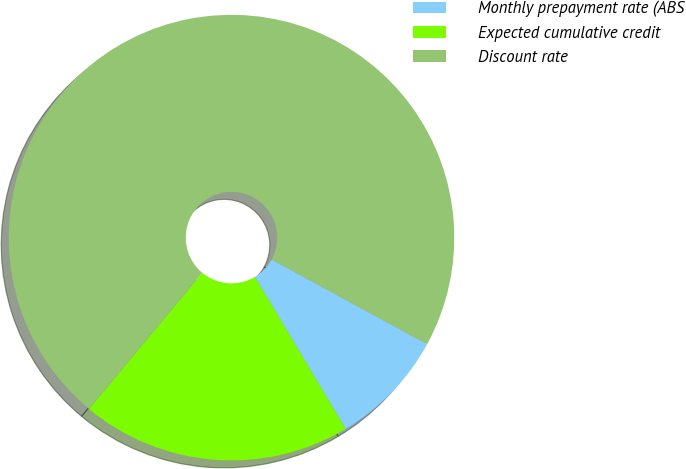Convert chart to OTSL. <chart><loc_0><loc_0><loc_500><loc_500><pie_chart><fcel>Monthly prepayment rate (ABS<fcel>Expected cumulative credit<fcel>Discount rate<nl><fcel>8.5%<fcel>19.61%<fcel>71.9%<nl></chart> 